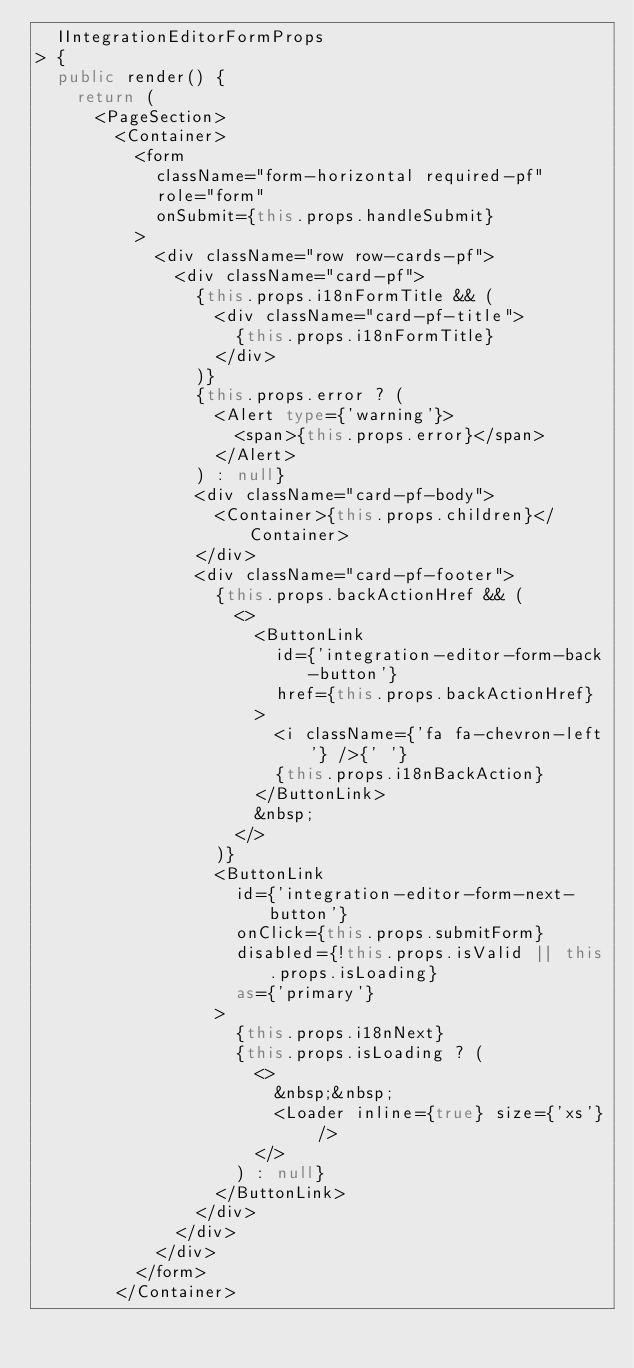<code> <loc_0><loc_0><loc_500><loc_500><_TypeScript_>  IIntegrationEditorFormProps
> {
  public render() {
    return (
      <PageSection>
        <Container>
          <form
            className="form-horizontal required-pf"
            role="form"
            onSubmit={this.props.handleSubmit}
          >
            <div className="row row-cards-pf">
              <div className="card-pf">
                {this.props.i18nFormTitle && (
                  <div className="card-pf-title">
                    {this.props.i18nFormTitle}
                  </div>
                )}
                {this.props.error ? (
                  <Alert type={'warning'}>
                    <span>{this.props.error}</span>
                  </Alert>
                ) : null}
                <div className="card-pf-body">
                  <Container>{this.props.children}</Container>
                </div>
                <div className="card-pf-footer">
                  {this.props.backActionHref && (
                    <>
                      <ButtonLink
                        id={'integration-editor-form-back-button'}
                        href={this.props.backActionHref}
                      >
                        <i className={'fa fa-chevron-left'} />{' '}
                        {this.props.i18nBackAction}
                      </ButtonLink>
                      &nbsp;
                    </>
                  )}
                  <ButtonLink
                    id={'integration-editor-form-next-button'}
                    onClick={this.props.submitForm}
                    disabled={!this.props.isValid || this.props.isLoading}
                    as={'primary'}
                  >
                    {this.props.i18nNext}
                    {this.props.isLoading ? (
                      <>
                        &nbsp;&nbsp;
                        <Loader inline={true} size={'xs'} />
                      </>
                    ) : null}
                  </ButtonLink>
                </div>
              </div>
            </div>
          </form>
        </Container></code> 